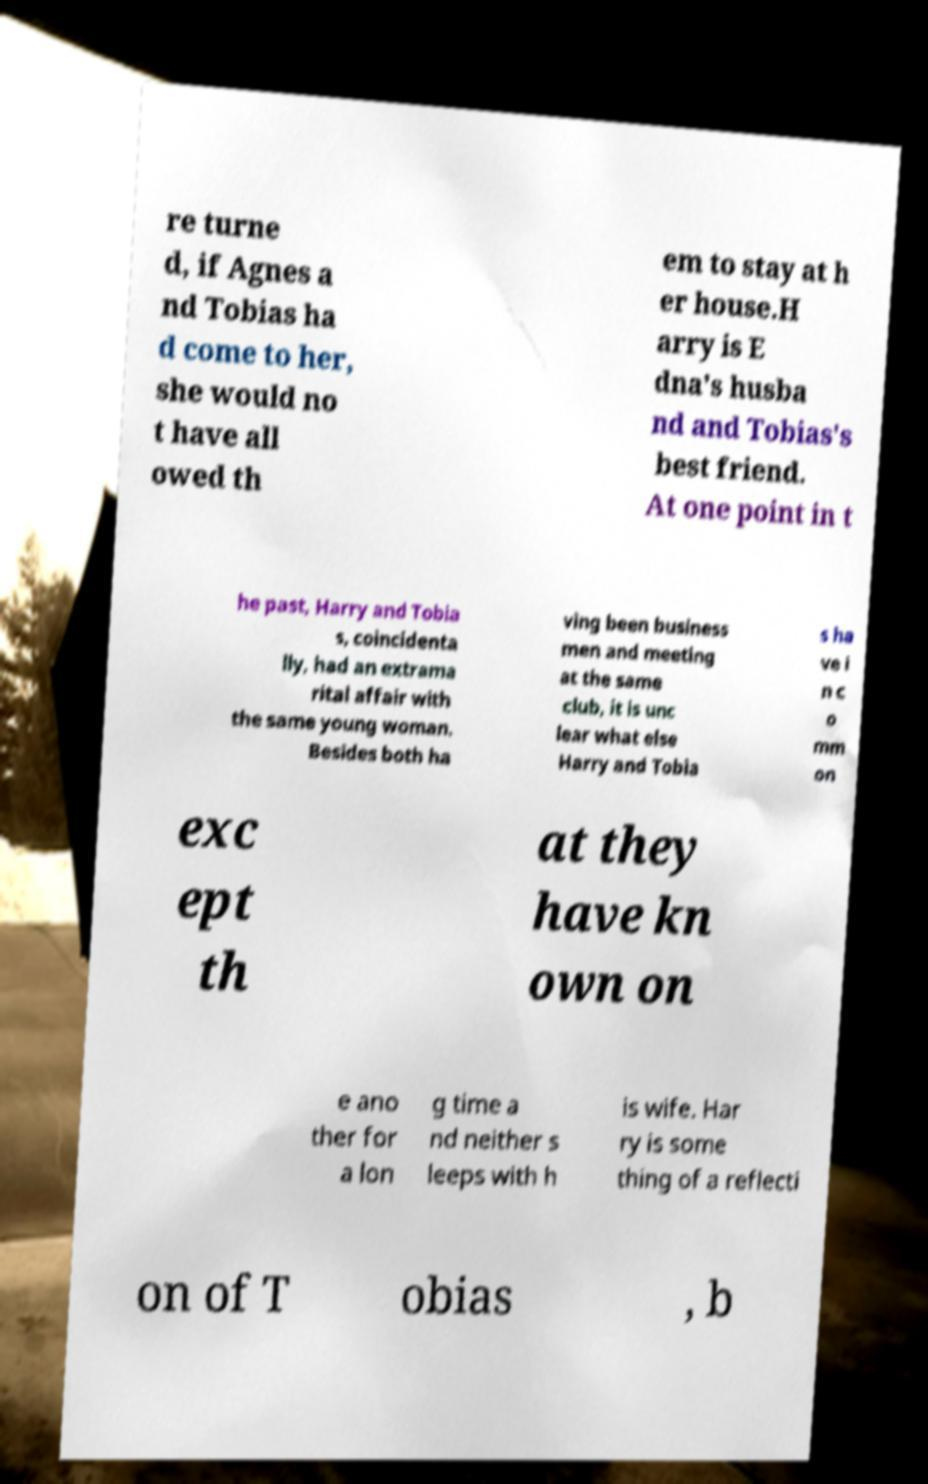Can you read and provide the text displayed in the image?This photo seems to have some interesting text. Can you extract and type it out for me? re turne d, if Agnes a nd Tobias ha d come to her, she would no t have all owed th em to stay at h er house.H arry is E dna's husba nd and Tobias's best friend. At one point in t he past, Harry and Tobia s, coincidenta lly, had an extrama rital affair with the same young woman. Besides both ha ving been business men and meeting at the same club, it is unc lear what else Harry and Tobia s ha ve i n c o mm on exc ept th at they have kn own on e ano ther for a lon g time a nd neither s leeps with h is wife. Har ry is some thing of a reflecti on of T obias , b 